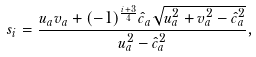<formula> <loc_0><loc_0><loc_500><loc_500>s _ { i } = \frac { u _ { a } v _ { a } + ( - 1 ) ^ { \frac { i + 3 } { 4 } } \hat { c } _ { a } \sqrt { u _ { a } ^ { 2 } + v _ { a } ^ { 2 } - \hat { c } _ { a } ^ { 2 } } } { u _ { a } ^ { 2 } - \hat { c } _ { a } ^ { 2 } } ,</formula> 